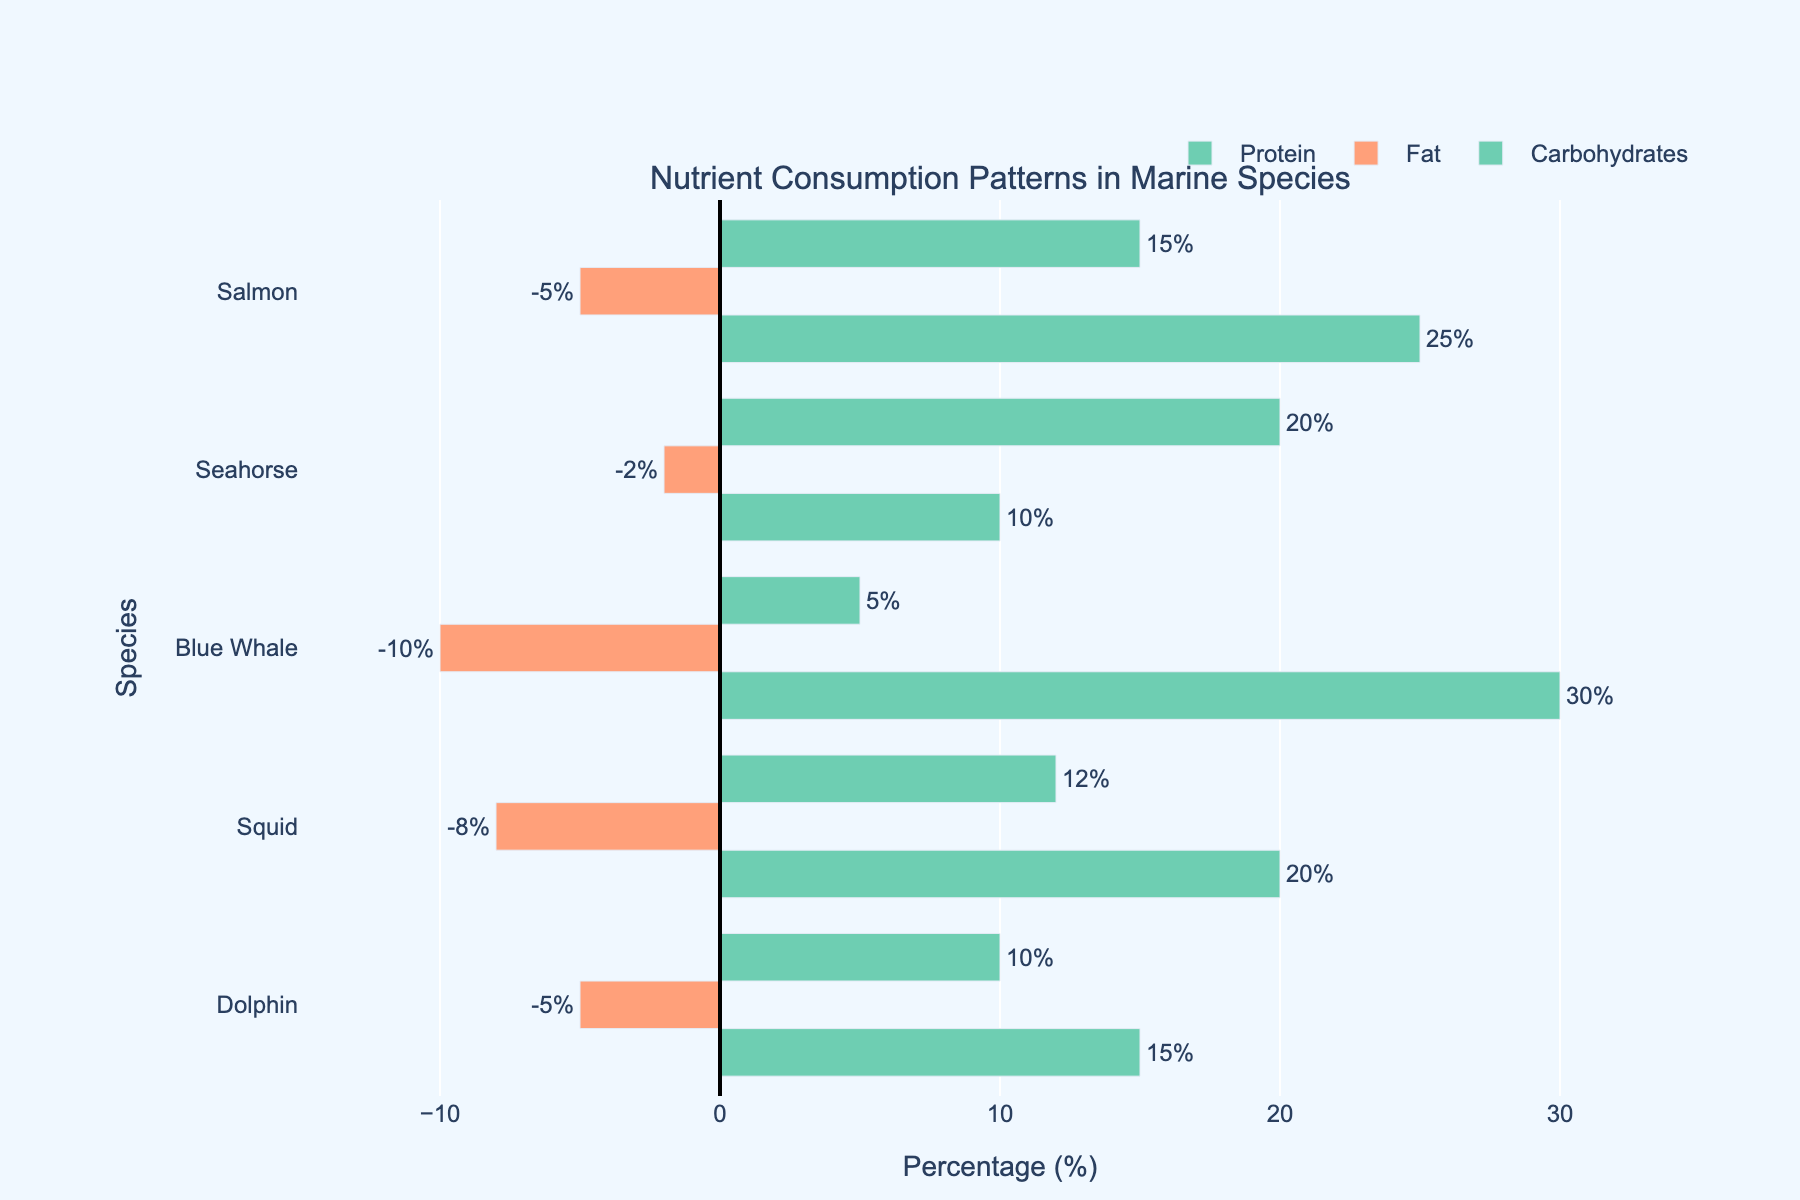Which species has the highest percentage of carbohydrates consumption? First, identify the carbohydrate data for each species; Blue Whale has 5%, Dolphin has 10%, Salmon has 15%, Seahorse has 20%, and Squid has 12%. Seahorse has the highest percentage.
Answer: Seahorse Which species has the lowest percentage of fat consumption? Review the fat data for each species; Blue Whale has -10%, Dolphin has -5%, Salmon has -5%, Seahorse has -2%, and Squid has -8%. Blue Whale has the lowest (most negative) percentage.
Answer: Blue Whale What is the average percentage of protein consumption across all species? Calculate the protein percentages: Dolphin (15), Blue Whale (30), Salmon (25), Seahorse (10), Squid (20). The total is 100. The average is 100/5 = 20%.
Answer: 20% Which species have both positive percentages for carbohydrates and proteins? Identify the positive values for both nutrients: Dolphin (Protein: 15, Carbohydrates: 10), Blue Whale (Protein: 30), Salmon (Protein: 25, Carbohydrates: 15), Seahorse (Protein: 10, Carbohydrates: 20), Squid (Protein: 20, Carbohydrates: 12). The species are Dolphin, Salmon, Seahorse, and Squid.
Answer: Dolphin, Salmon, Seahorse, Squid What is the difference in fat percentage between Squid and Dolphin? Squid's fat percentage is -8% and Dolphin's is -5%. The difference is -8 - (-5) = -8 + 5 = -3%.
Answer: -3% Compare the total consumption (sum of all nutrient percentages) of Dolphin and Blue Whale. Which is higher? Calculate the total for Dolphin (Protein: 15 + Fat: -5 + Carbohydrates: 10 = 20). Calculate the total for Blue Whale (Protein: 30 + Fat: -10 + Carbohydrates: 5 = 25). Blue Whale has a higher total consumption.
Answer: Blue Whale Which species has the closest protein consumption percentage to Squid? Squid's protein percentage is 20%. Compare it with Dolphin (15), Blue Whale (30), Salmon (25), Seahorse (10). Salmon (25) is the closest.
Answer: Salmon Considering only the species with positive fat percentages, what is the combined percentage for all their nutrients? There are no species with positive fat percentages.
Answer: 0 